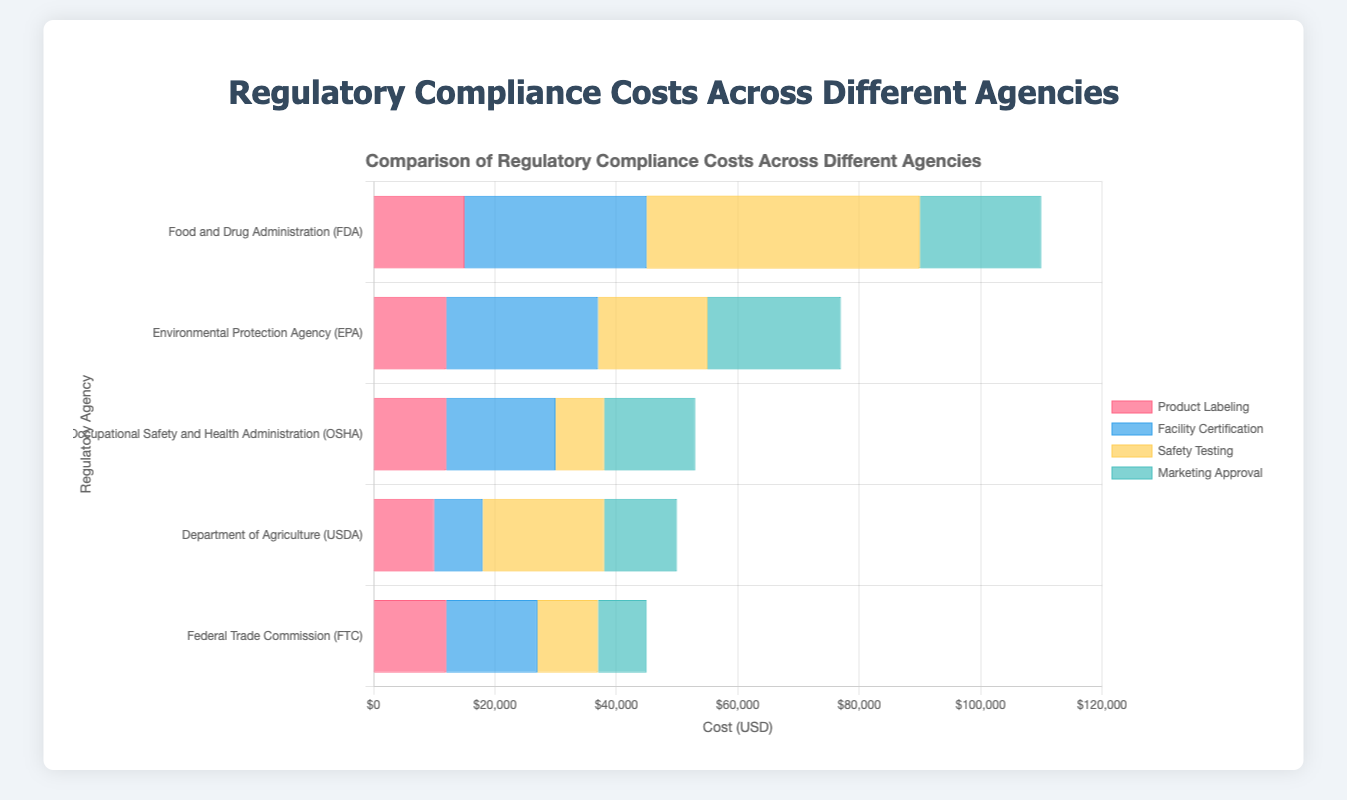Which regulatory agency has the highest total compliance cost? Sum up the costs for each agency and compare. The FDA has total costs of $15000 + $30000 + $45000 + $20000 = $110000. The other agencies have lower total costs.
Answer: FDA Which category has the lowest compliance cost under FDA? Compare the costs of each category under FDA: Product Labeling ($15000), Facility Certification ($30000), Safety Testing ($45000), and Marketing Approval ($20000). The lowest cost is for Product Labeling.
Answer: Product Labeling Which category under the USDA has a compliance cost equal to or greater than $20000? Check each category's cost under USDA: Crop Certification ($10000), Pesticide Use Reporting ($8000), Organic Certification ($20000), Soil Testing ($12000). Only Organic Certification has a cost equal to $20000.
Answer: Organic Certification What is the difference in total compliance costs between the EPA and OSHA? Sum the costs for EPA and OSHA: EPA ($12000 + $25000 + $18000 + $22000 = $77000) and OSHA ($12000 + $18000 + $8000 + $15000 = $53000). The difference is $77000 - $53000 = $24000.
Answer: $24000 Which category under OSHA has the highest compliance cost? Compare the costs of each category under OSHA: Workplace Safety Training ($12000), Safety Equipment ($18000), Accident Reporting ($8000), Compliance Audits ($15000). The highest cost is for Safety Equipment.
Answer: Safety Equipment What is the average compliance cost per category under FTC? Sum the costs and divide by the number of categories: ($12000 + $15000 + $10000 + $8000) / 4 = $11250.
Answer: $11250 How does the cost of Safety Testing under FDA compare with that of Hazardous Material Handling under EPA? Safety Testing under FDA costs $45000, and Hazardous Material Handling under EPA costs $22000. $45000 is greater than $22000.
Answer: Safety Testing under FDA is higher Estimate the visual length ratio of the Safety Equipment bar under OSHA to the Accident Reporting bar under OSHA. Visually inspect the bar lengths under OSHA. The Safety Equipment bar is more than twice as long as the Accident Reporting bar, roughly around 2.25 times longer.
Answer: Approximately 2.25 Which category under FTC has the shortest compliance cost bar visually? Visually examine the bars under FTC. The Label Claims Verification bar is the shortest.
Answer: Label Claims Verification What is the combined compliance cost for Facility Certification and Safety Testing under FDA? Add the costs of Facility Certification ($30000) and Safety Testing ($45000) under FDA: $30000 + $45000 = $75000.
Answer: $75000 